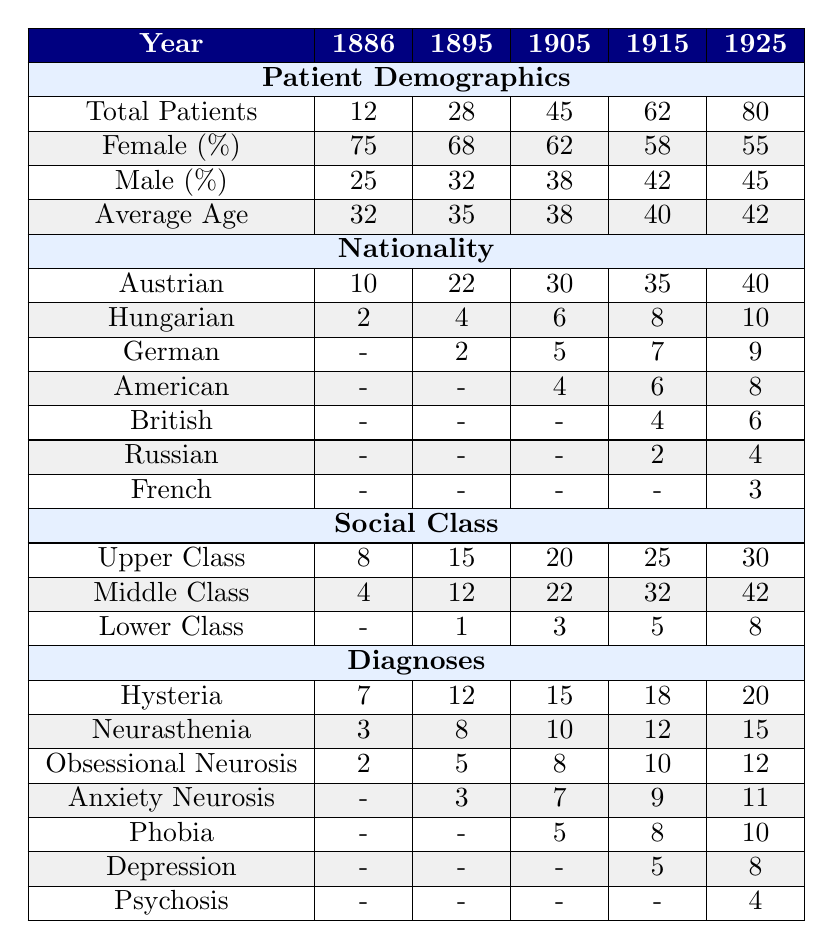What was the total number of patients Freud saw in 1905? The table shows the total patients for each year. For 1905, the total patients listed is 45.
Answer: 45 What percentage of Freud's patients were female in 1915? The table indicates that in 1915, the female percentage is 58%.
Answer: 58% How many hysteria cases did Freud diagnose in 1925? According to the table, in 1925, the number of hysteria cases is listed as 20.
Answer: 20 What was the average age of Freud's patients across all years? To find the average age across all years, we sum the average ages: (32 + 35 + 38 + 40 + 42) = 187, then divide by 5, resulting in 187 / 5 = 37.4.
Answer: 37.4 Did the percentage of male patients increase or decrease from 1886 to 1925? In 1886, the male percentage was 25%, and in 1925, it was 45%. Therefore, the percentage increased over this time period.
Answer: Increased What is the total number of neuroses cases (including hysteria, neurasthenia, obsessional neurosis, anxiety neurosis, phobia, and depression) diagnosed in 1915? The total for 1915 can be calculated by adding the respective cases: 18 (hysteria) + 12 (neurasthenia) + 10 (obsessional neurosis) + 9 (anxiety neurosis) + 8 (phobia) + 5 (depression) = 62.
Answer: 62 Which year had the highest proportion of patients from the upper class? By looking at the table, in 1925, the upper-class patients were 30, which is higher compared to all other years.
Answer: 1925 How many more Austrian patients did Freud have in 1925 compared to 1886? In 1886, Freud had 10 Austrian patients, and in 1925, he had 40. The difference is 40 - 10 = 30.
Answer: 30 Was the number of American patients the same in both 1905 and 1915? The table shows that in 1905 there were 4 American patients, while in 1915 there were 6. This means the numbers were not the same.
Answer: No What was the increase in the total number of patients from 1915 to 1925? In 1915, the total patients were 62, and in 1925, they were 80. Therefore, the increase is 80 - 62 = 18.
Answer: 18 Was the percentage of female patients higher in 1895 than in 1905? In 1895, the female percentage was 68%, while in 1905 it was 62%. Therefore, it was higher in 1895.
Answer: Yes 